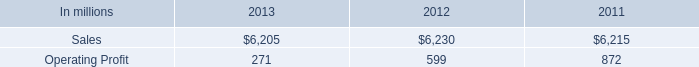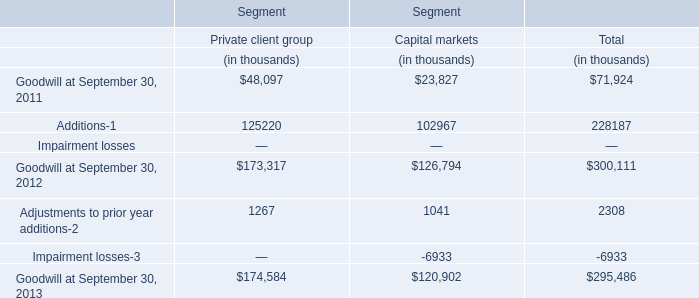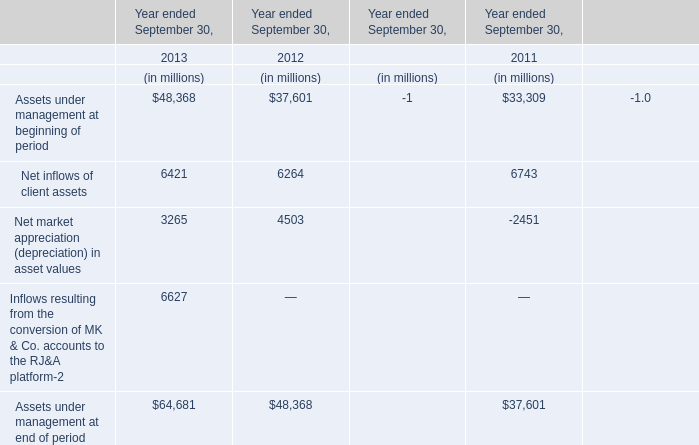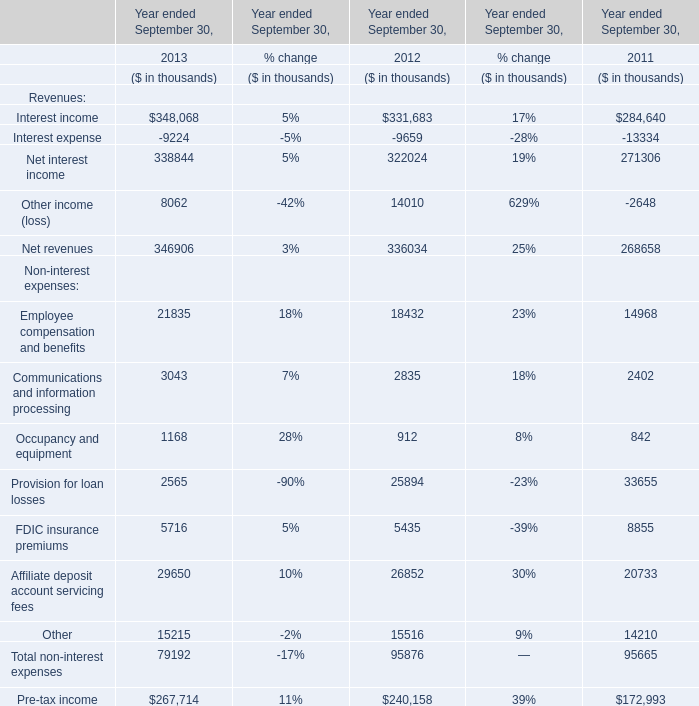in 2012 what percentage of printing papers sales where attributable to north american printing papers net sales? 
Computations: ((2.7 * 1000) / 6230)
Answer: 0.43339. 